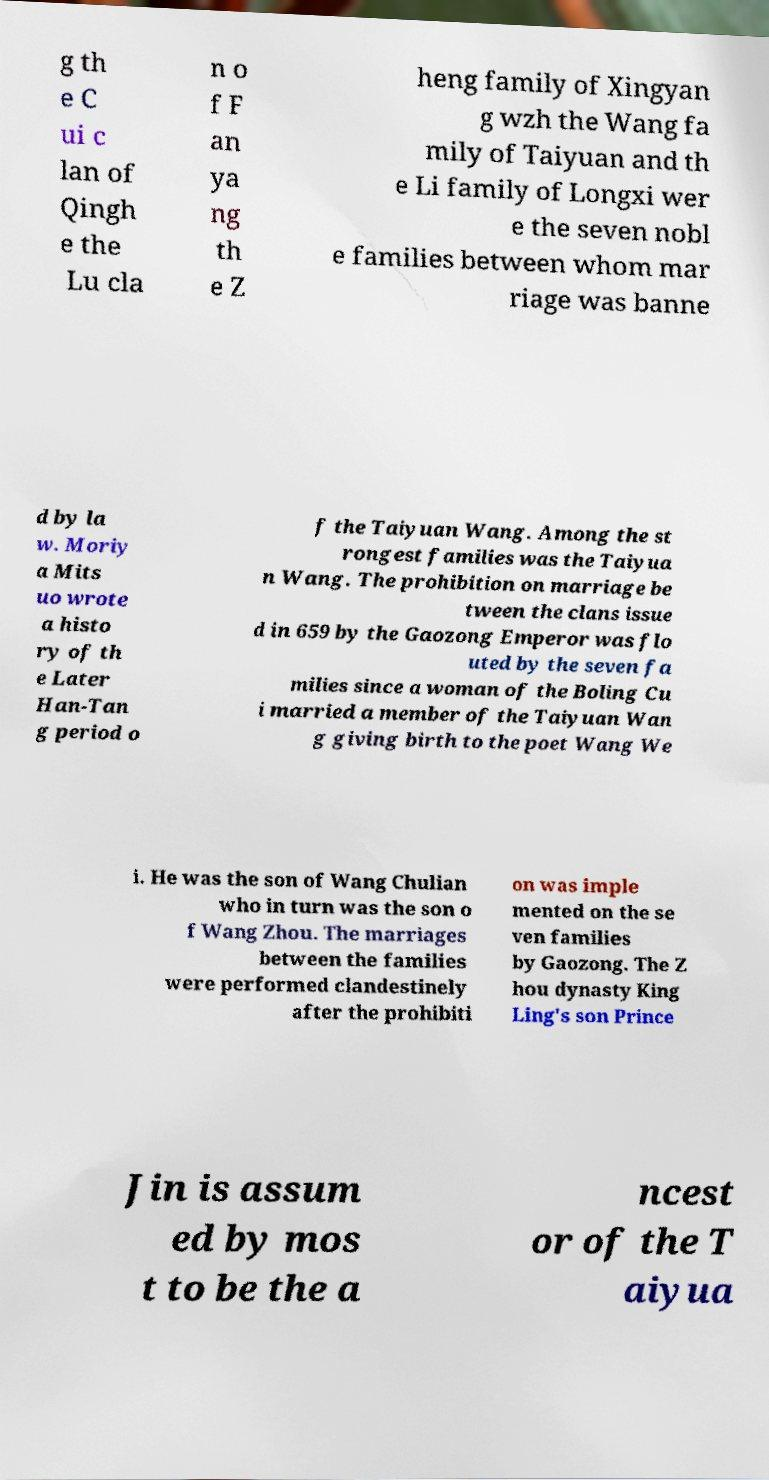I need the written content from this picture converted into text. Can you do that? g th e C ui c lan of Qingh e the Lu cla n o f F an ya ng th e Z heng family of Xingyan g wzh the Wang fa mily of Taiyuan and th e Li family of Longxi wer e the seven nobl e families between whom mar riage was banne d by la w. Moriy a Mits uo wrote a histo ry of th e Later Han-Tan g period o f the Taiyuan Wang. Among the st rongest families was the Taiyua n Wang. The prohibition on marriage be tween the clans issue d in 659 by the Gaozong Emperor was flo uted by the seven fa milies since a woman of the Boling Cu i married a member of the Taiyuan Wan g giving birth to the poet Wang We i. He was the son of Wang Chulian who in turn was the son o f Wang Zhou. The marriages between the families were performed clandestinely after the prohibiti on was imple mented on the se ven families by Gaozong. The Z hou dynasty King Ling's son Prince Jin is assum ed by mos t to be the a ncest or of the T aiyua 